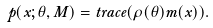<formula> <loc_0><loc_0><loc_500><loc_500>p ( x ; \theta , M ) = t r a c e ( \rho ( \theta ) m ( x ) ) .</formula> 